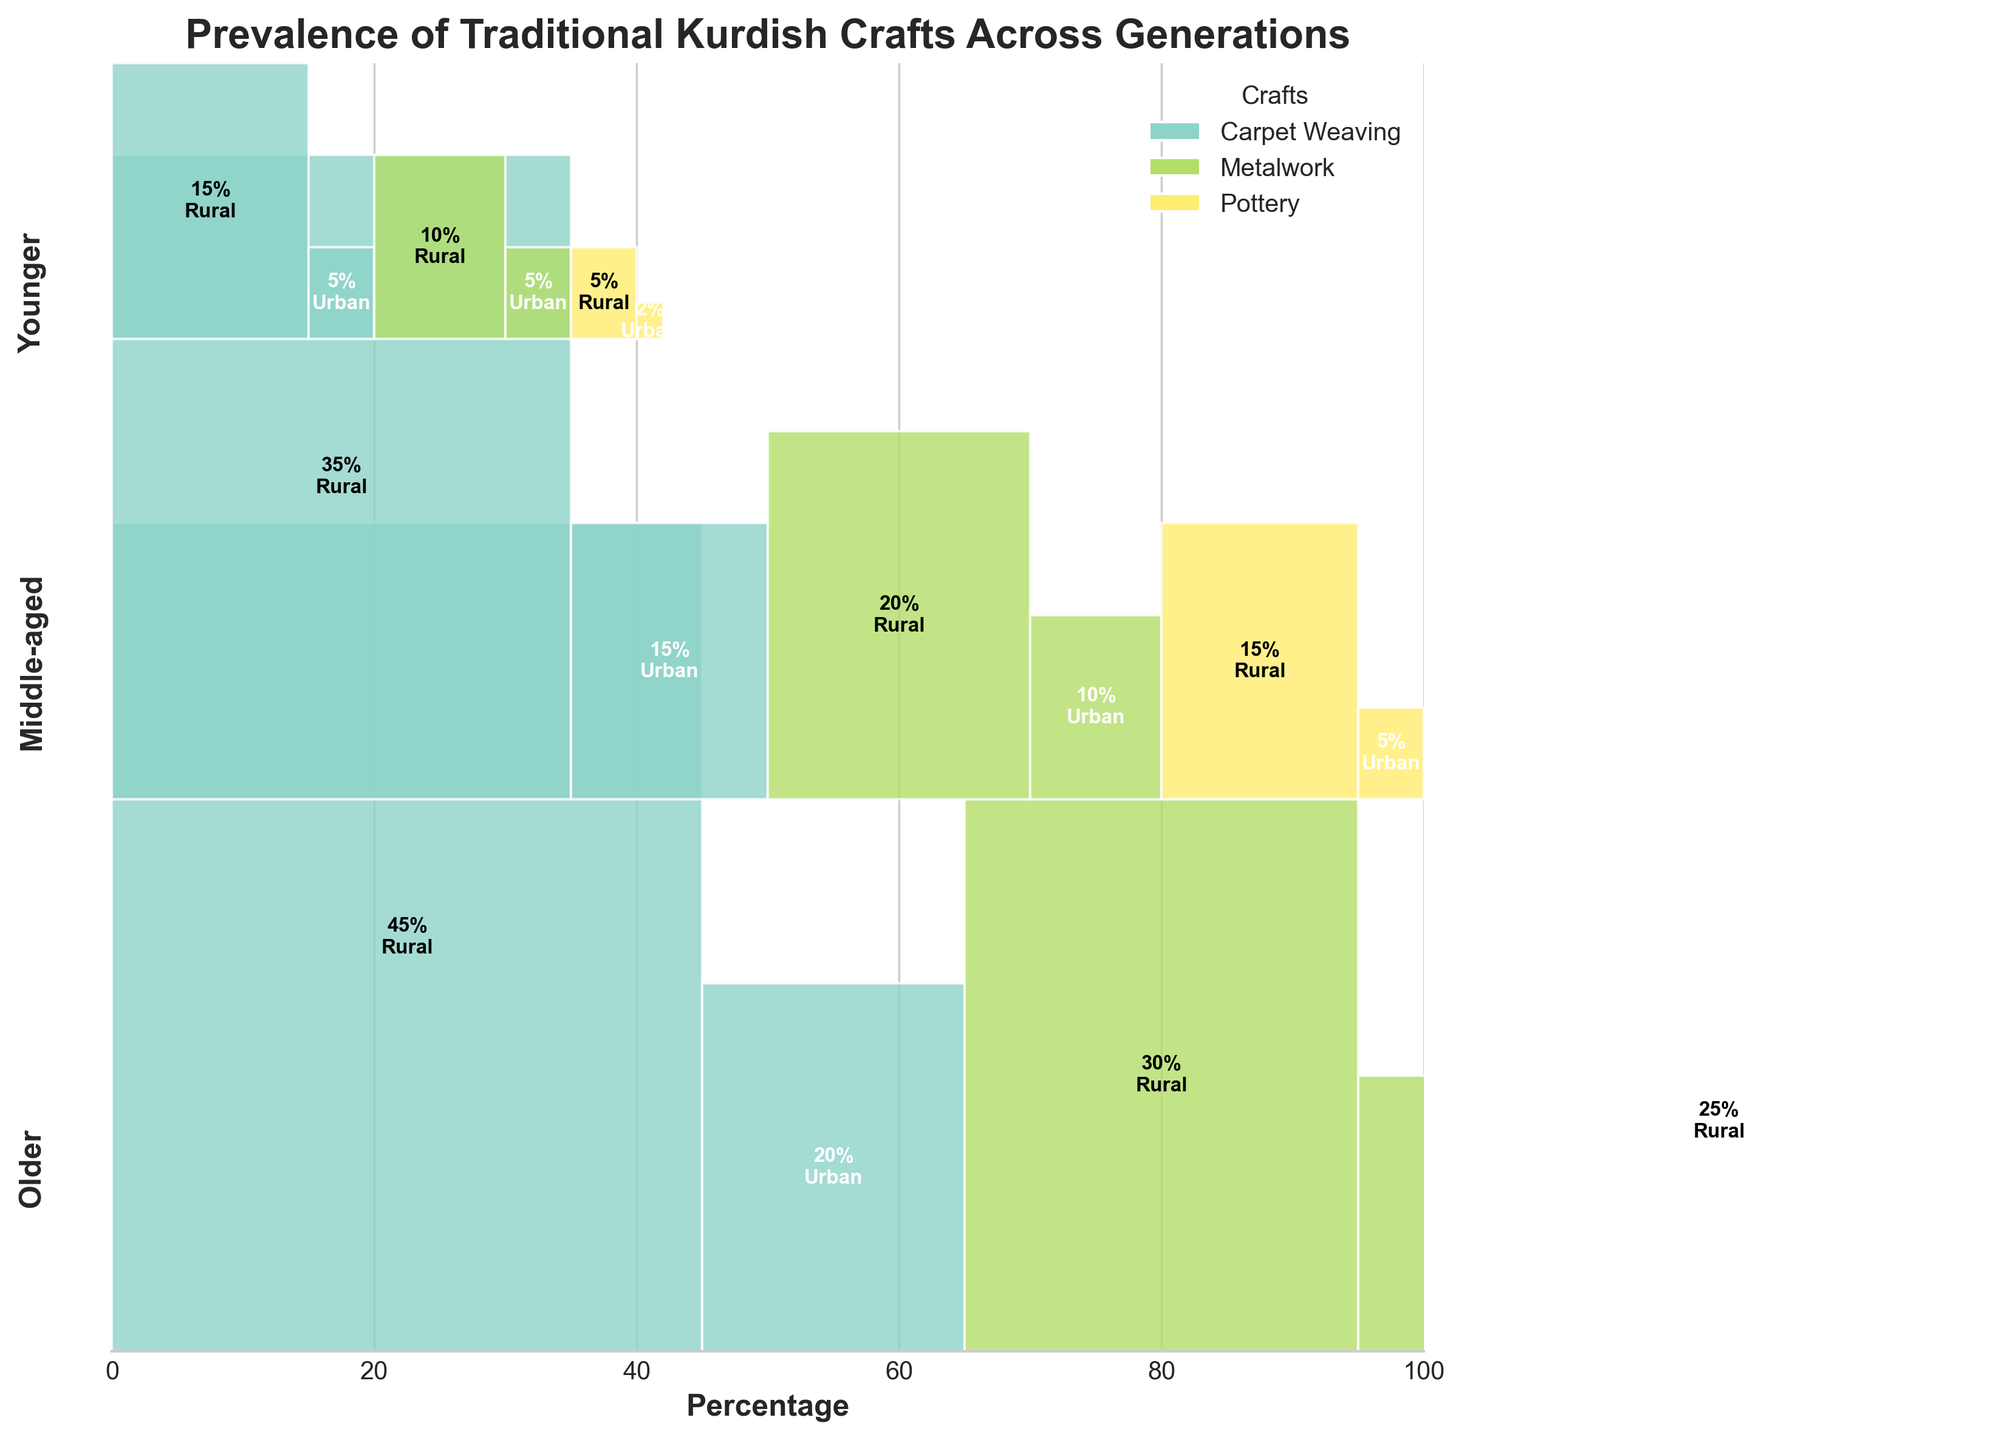What is the title of the plot? The title of the plot is displayed at the top and provides an overview of the subject of the figure. It reads "Prevalence of Traditional Kurdish Crafts Across Generations".
Answer: Prevalence of Traditional Kurdish Crafts Across Generations Which craft has the highest prevalence in the Older generation in rural areas? By looking at the section of the plot corresponding to the Older generation and rural areas, Carpet Weaving shows the highest percentage (45%).
Answer: Carpet Weaving How does the prevalence of Metalwork in urban areas compare between the Middle-aged and Younger generations? For the Middle-aged generation, the prevalence is 10%. For the Younger generation, the prevalence is 5%. By comparing these values, it is clear that the Middle-aged generation has a higher prevalence by 5 percentage points.
Answer: Middle-aged has a higher prevalence Which generation has the lowest prevalence of each craft in rural areas? The generation with the lowest prevalence for each craft in rural areas can be observed from the lowest value in each craft's bar: Carpet Weaving (Younger, 15%), Metalwork (Younger, 10%), and Pottery (Younger, 5%).
Answer: Younger for all crafts What is the combined prevalence of Carpet Weaving and Metalwork in urban areas for the Older generation? This requires adding the prevalence percentages for Carpet Weaving (20%) and Metalwork (15%) for the Older generation in urban areas. 20% + 15% = 35%.
Answer: 35% Compare the prevalence of Pottery in Rural areas across all generations. In the Rural area, the plot shows Pottery prevalence as: Older (25%), Middle-aged (15%), and Younger (5%). The trend shows a decline in prevalence from Older to Younger generations.
Answer: Declines from Older to Younger Which craft shows the most significant decrease in prevalence from the Older to the Younger generation in Rural areas? By comparing the prevalence values, Carpet Weaving decreases from 45% in the Older to 15% in the Younger generation, making it the most significant decrease (30%).
Answer: Carpet Weaving What is the total prevalence of traditional Kurdish crafts in urban areas for the Younger generation? Adding the percentages for each craft in urban areas for the Younger generation: Carpet Weaving (5%), Metalwork (5%), and Pottery (2%). The total is 5% + 5% + 2% = 12%.
Answer: 12% What percentage of the Middle-aged generation participates in Pottery in urban areas? Looking at the Middle-aged generation and the Pottery category in urban areas, the plot shows a percentage of 5%.
Answer: 5% Which generation shows the highest disparity between urban and rural areas in terms of Metalwork prevalence? By comparing the differences in urban and rural percentages for each generation: Older (30% - 15% = 15%), Middle-aged (20% - 10% = 10%), and Younger (10% - 5% = 5%). The Older generation shows the highest disparity of 15%.
Answer: Older generation 